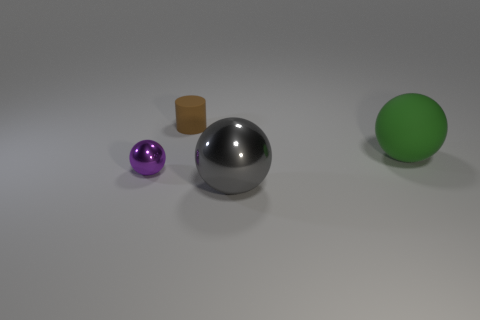What material is the thing that is to the left of the object behind the big matte sphere?
Make the answer very short. Metal. What is the color of the matte sphere?
Your answer should be compact. Green. Is the color of the metal object that is to the left of the small brown matte cylinder the same as the large thing behind the small purple thing?
Your answer should be compact. No. There is a gray thing that is the same shape as the green thing; what size is it?
Give a very brief answer. Large. Are there any big balls that have the same color as the large metallic object?
Ensure brevity in your answer.  No. What number of objects are shiny spheres on the left side of the tiny brown cylinder or purple metal objects?
Your response must be concise. 1. What is the color of the large sphere that is the same material as the tiny cylinder?
Your answer should be very brief. Green. Are there any green cylinders of the same size as the purple metallic ball?
Offer a very short reply. No. What number of objects are big balls to the right of the gray shiny sphere or green things that are behind the tiny purple shiny sphere?
Provide a short and direct response. 1. What shape is the brown matte object that is the same size as the purple shiny ball?
Your answer should be very brief. Cylinder. 